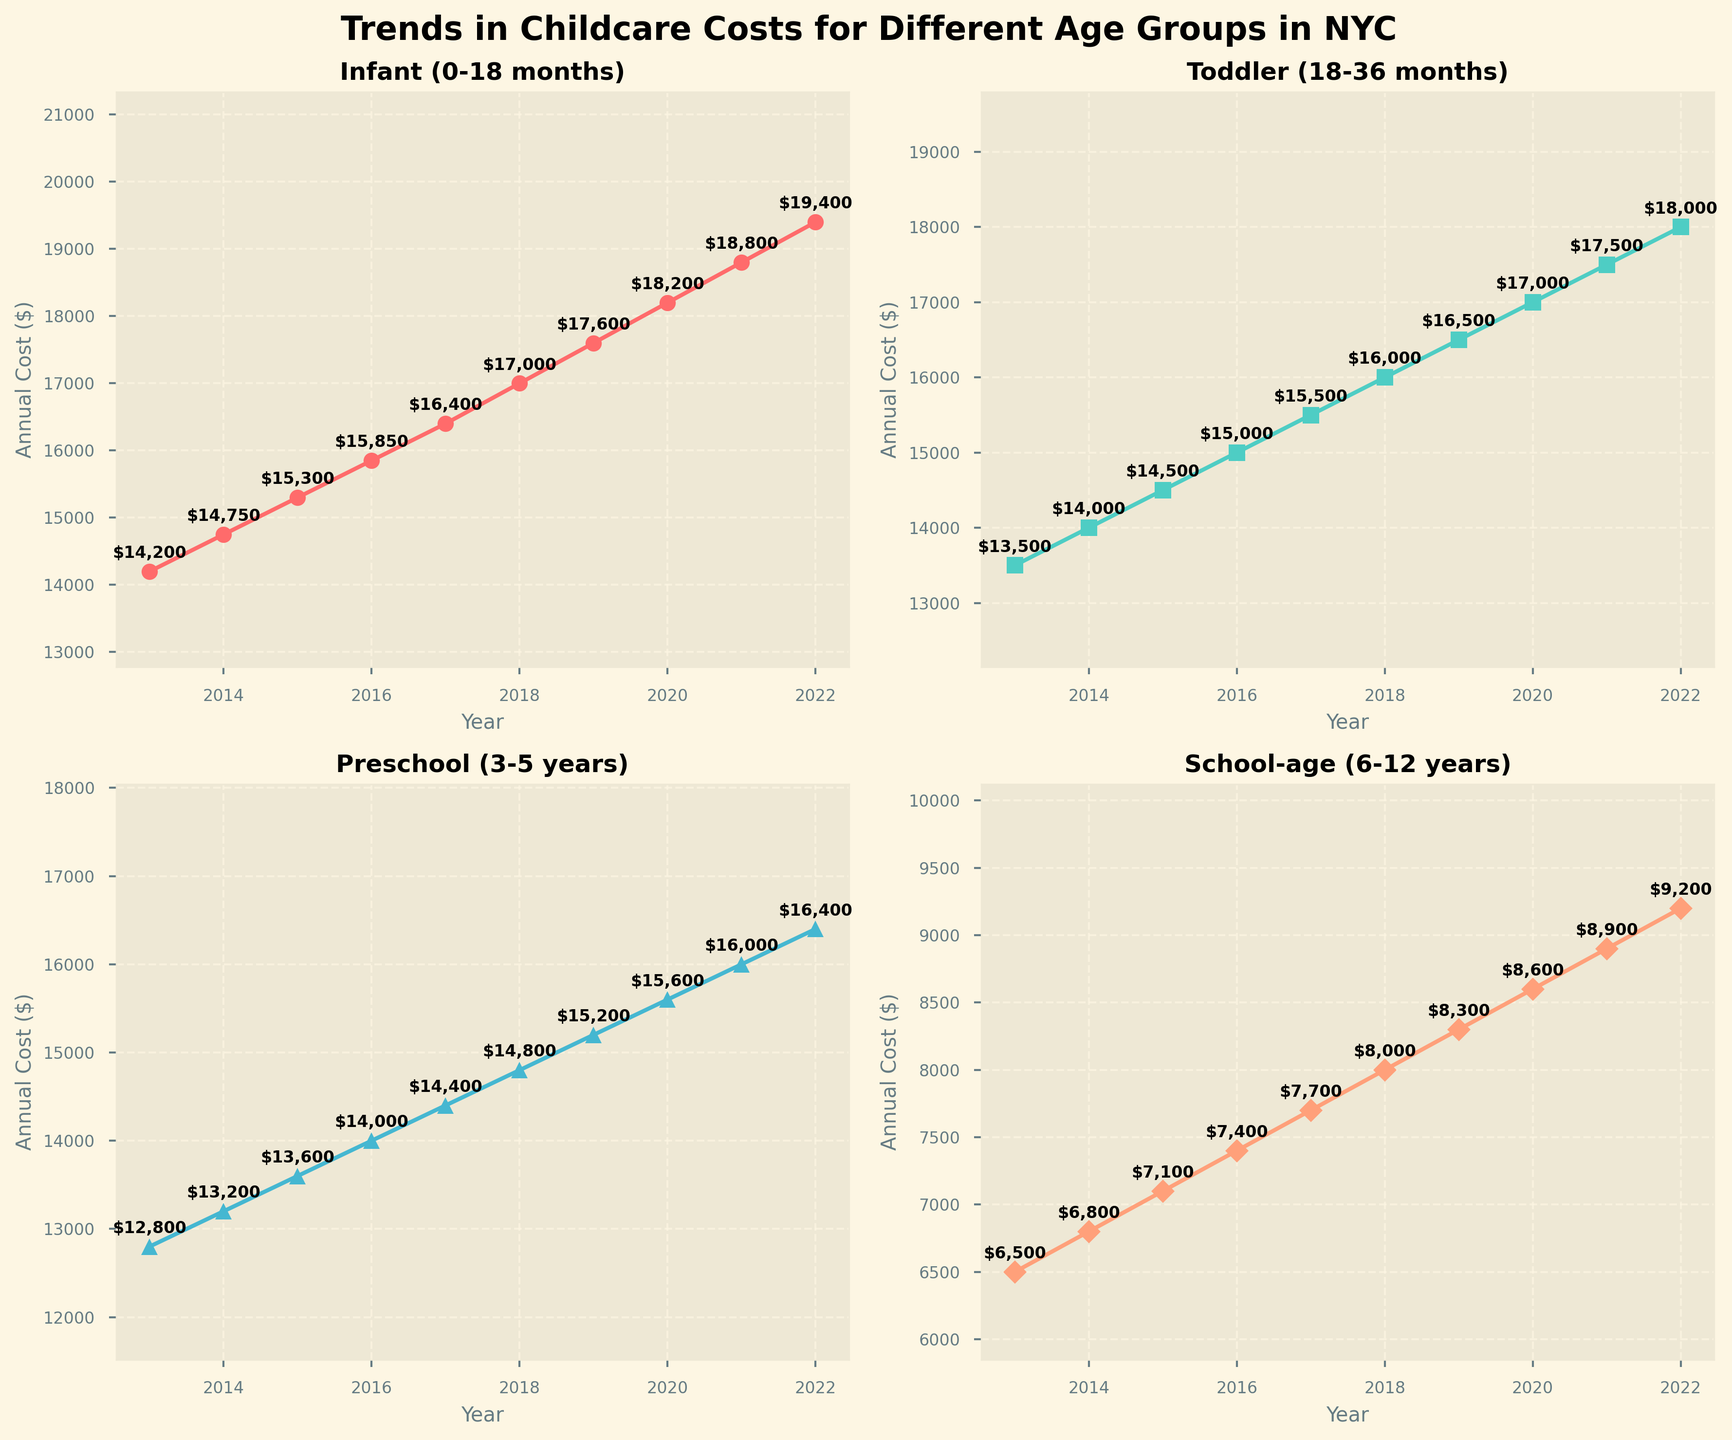What's the trend in childcare costs for infants over the last decade? The plot shows a consistent upward trend in the annual costs for infants from $14,200 in 2013 to $19,400 in 2022.
Answer: Steady increase Which age group saw the smallest increase in childcare costs from 2013 to 2022? By looking at the start and end values for each age group, we calculate the differences. Infant increased by 5,200, Toddler by 4,500, Preschool by 3,600, and School-age by 2,700. School-age group had the smallest increase.
Answer: School-age Compare the childcare costs for toddlers and infants in 2022. In 2022, the plot shows $18,000 for toddlers and $19,400 for infants.
Answer: Infants cost more by $1,400 Which age group had the highest annual cost in 2019? According to the 2019 plots, Infant has $17,600, Toddler has $16,500, Preschool has $15,200, and School-age has $8,300, making Infant the highest.
Answer: Infant What is the difference between the childcare costs for school-age children and preschool children in 2020? In 2020, School-age costs $8,600 while Preschool costs $15,600. The difference is $15,600 - $8,600 = $7,000.
Answer: $7,000 Which age group experienced the most rapid cost growth rate from 2013 to 2018? By calculating the percentage increase: Infant (19.7%), Toddler (18.5%), Preschool (15.6%), and School-age (23.1%). School-age experienced the highest growth rate.
Answer: School-age What's the average annual cost for a toddler over the last decade? Adding up annual costs from 2013 to 2022 ($13500 + $14000 + $14500 + $15000 + $15500 + $16000 + $16500 + $17000 + $17500 + $18000) equals $147,500. Dividing by 10 gives the average: $14,750.
Answer: $14,750 How much more expensive was childcare for an infant compared to a preschooler in 2022? In 2022, Infant costs $19,400 while Preschool costs $16,400. The difference is $19,400 - $16,400 = $3,000.
Answer: $3,000 By how much did the annual childcare costs for toddlers increase from 2016 to 2020? From the chart, in 2016, Toddler costs $15,000, and in 2020, it costs $17,000. The increase is $17,000 - $15,000 = $2,000.
Answer: $2,000 